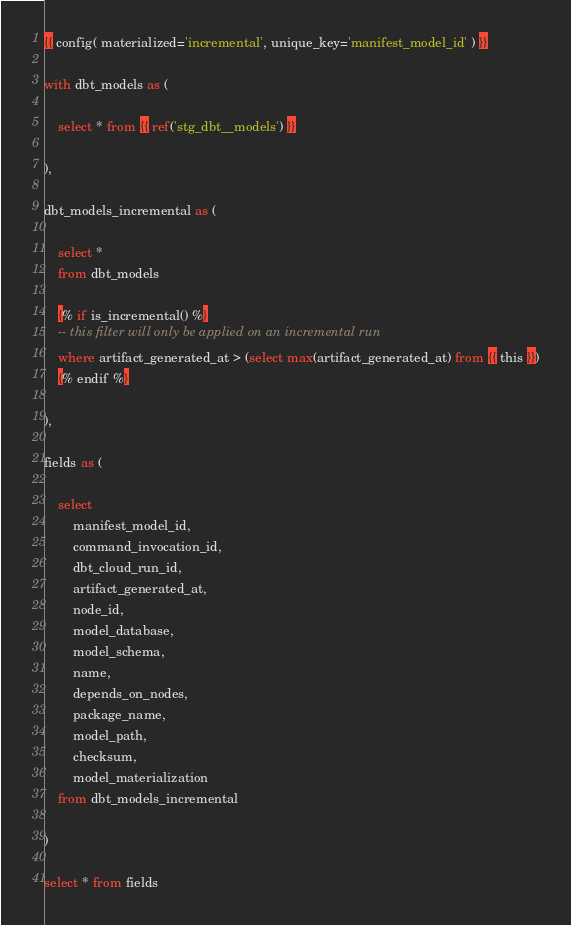Convert code to text. <code><loc_0><loc_0><loc_500><loc_500><_SQL_>{{ config( materialized='incremental', unique_key='manifest_model_id' ) }}

with dbt_models as (

    select * from {{ ref('stg_dbt__models') }}

),

dbt_models_incremental as (

    select *
    from dbt_models

    {% if is_incremental() %}
    -- this filter will only be applied on an incremental run
    where artifact_generated_at > (select max(artifact_generated_at) from {{ this }})
    {% endif %}

),

fields as (

    select
        manifest_model_id,
        command_invocation_id,
        dbt_cloud_run_id,
        artifact_generated_at,
        node_id,
        model_database,
        model_schema,
        name,
        depends_on_nodes,
        package_name,
        model_path,
        checksum,
        model_materialization
    from dbt_models_incremental

)

select * from fields
</code> 